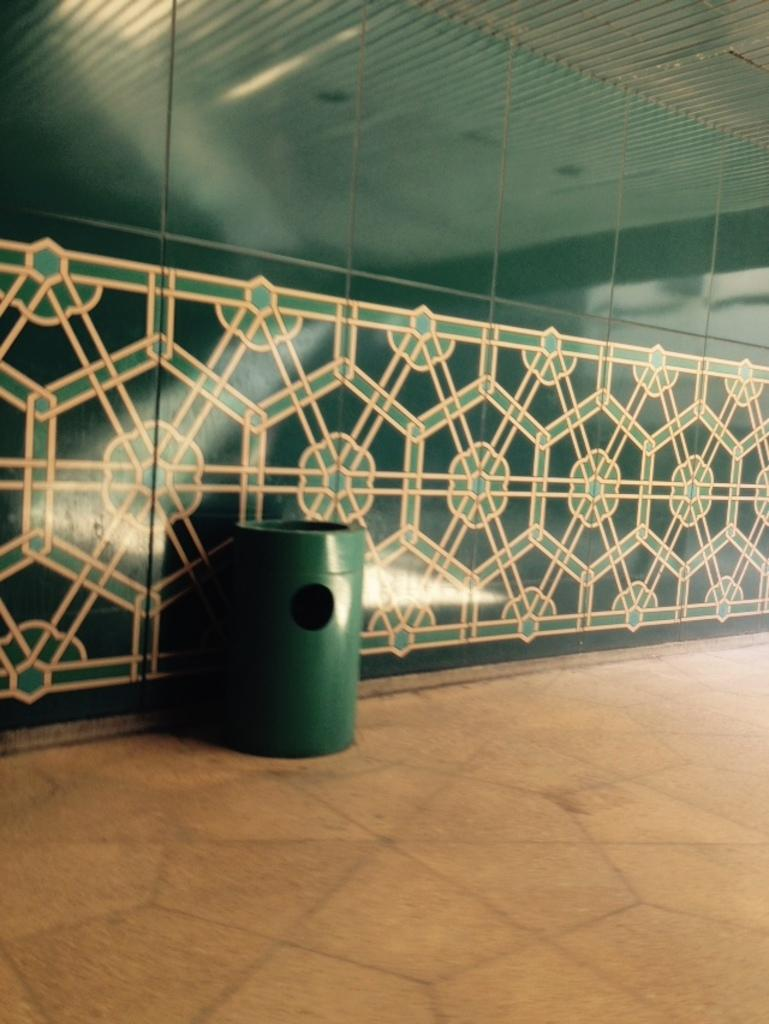What is one of the main objects in the image? There is a wall in the image. What other object can be seen in the image? There is a dustbin in the image. What is the color of the dustbin? The dustbin is green in color. Are there any carriages visible in the image? There are no carriages present in the image. How many trees can be seen in the image? There are no trees visible in the image. 